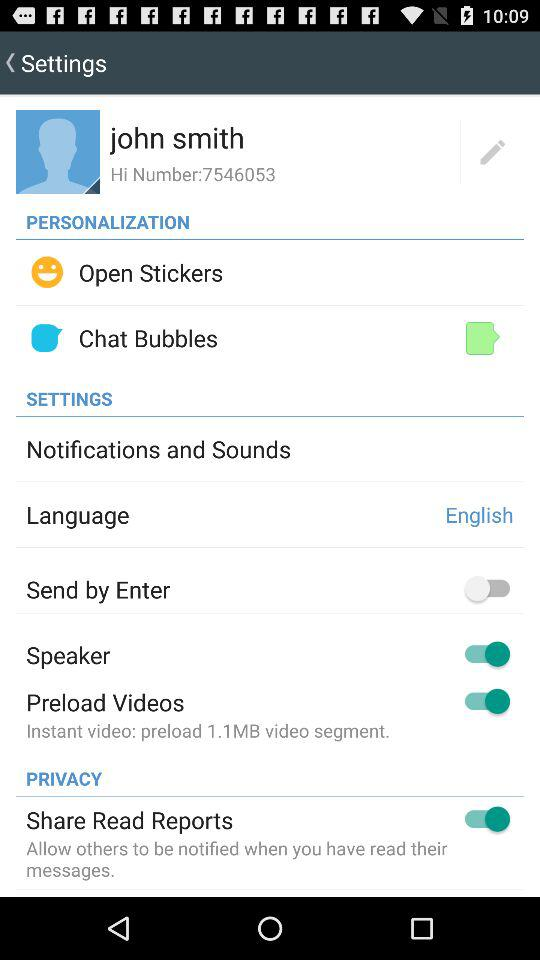Which chat setting is shown here?
When the provided information is insufficient, respond with <no answer>. <no answer> 